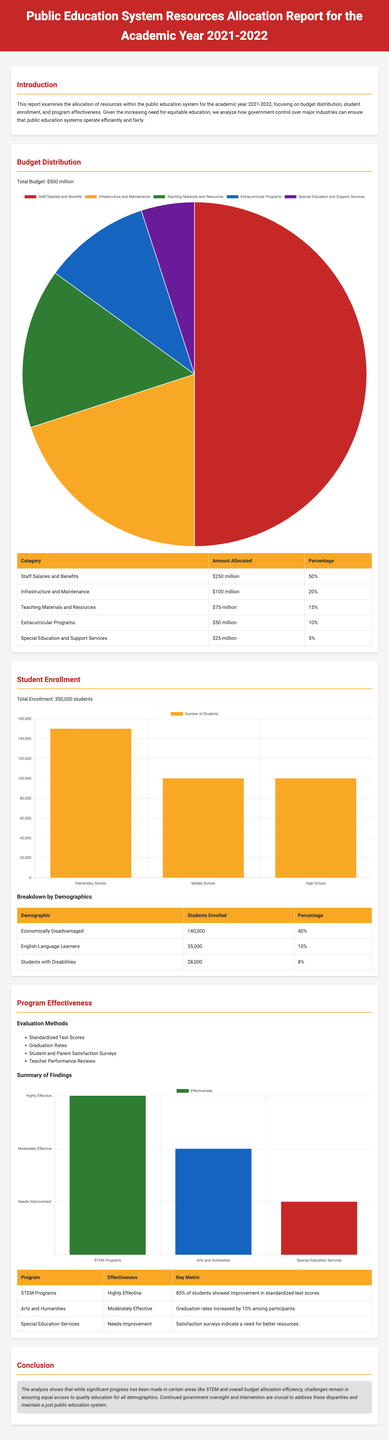What is the total budget for the academic year? The total budget is presented in the budget distribution section of the document as $500 million.
Answer: $500 million What percentage of the budget is allocated to staff salaries and benefits? The document specifies that 50% of the total budget is allocated to staff salaries and benefits.
Answer: 50% How many students are enrolled in the public education system? The total enrollment number is stated in the student enrollment section as 350,000 students.
Answer: 350,000 students What is the effectiveness rating of STEM programs? The effectiveness of STEM programs is described in the effectiveness section, rated as highly effective.
Answer: Highly Effective How many students are identified as economically disadvantaged? The document provides the figure of 140,000 students classified as economically disadvantaged in the enrollment breakdown.
Answer: 140,000 What is the total amount allocated for extracurricular programs? The total allocated amount for extracurricular programs is detailed in the budget distribution table as $50 million.
Answer: $50 million What demographic represents 10% of the total student enrollment? The document indicates that English Language Learners make up 10% of the total student enrollment.
Answer: English Language Learners Which program shows a need for improvement according to the effectiveness evaluation? In the program effectiveness table, special education services are identified as needing improvement.
Answer: Special Education Services What is the total number of students in high school? The document specifies that there are 100,000 students enrolled in high school.
Answer: 100,000 